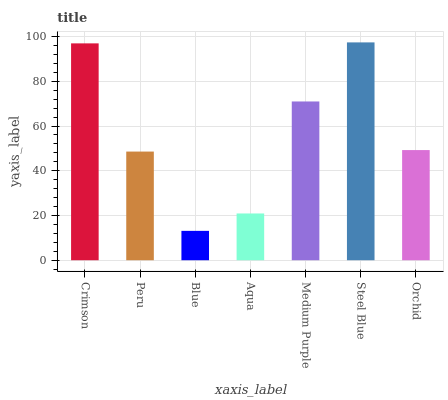Is Blue the minimum?
Answer yes or no. Yes. Is Steel Blue the maximum?
Answer yes or no. Yes. Is Peru the minimum?
Answer yes or no. No. Is Peru the maximum?
Answer yes or no. No. Is Crimson greater than Peru?
Answer yes or no. Yes. Is Peru less than Crimson?
Answer yes or no. Yes. Is Peru greater than Crimson?
Answer yes or no. No. Is Crimson less than Peru?
Answer yes or no. No. Is Orchid the high median?
Answer yes or no. Yes. Is Orchid the low median?
Answer yes or no. Yes. Is Aqua the high median?
Answer yes or no. No. Is Crimson the low median?
Answer yes or no. No. 